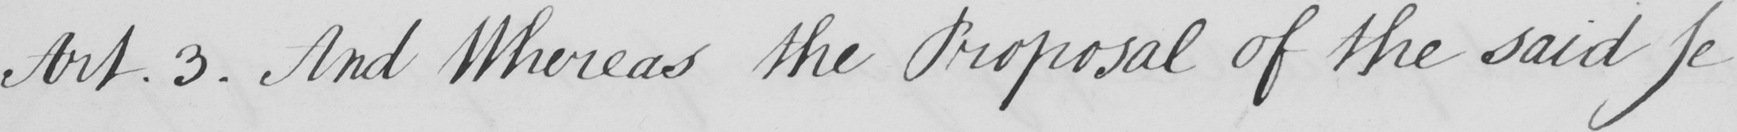Can you read and transcribe this handwriting? Art.3 . And Whereas the Proposal of the said Je 